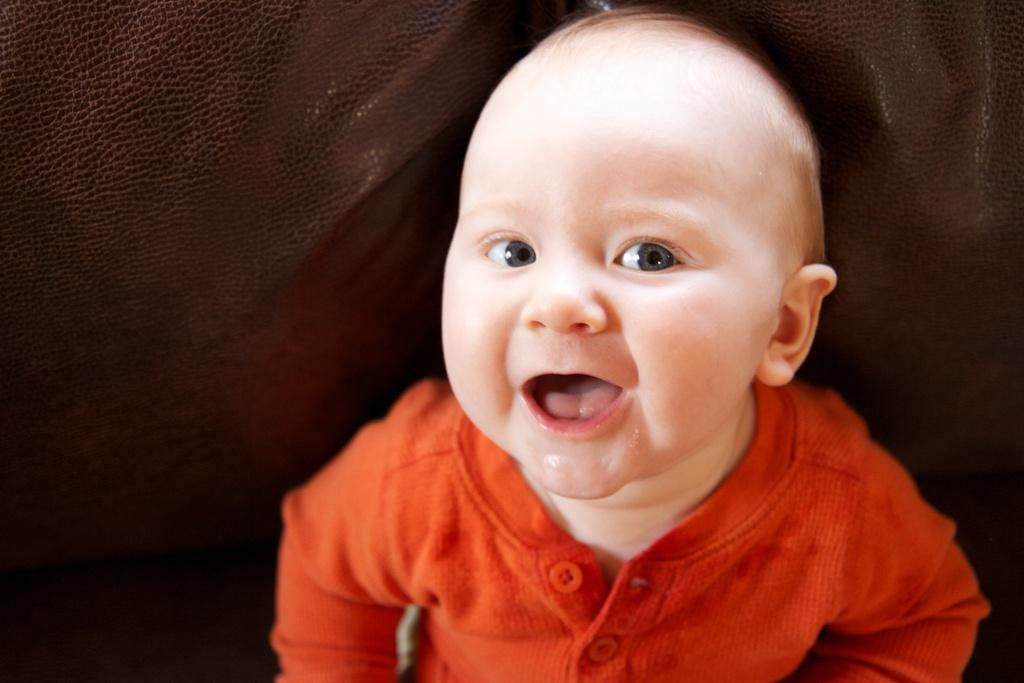What is the main subject of the picture? The main subject of the picture is a boy. What is the boy wearing in the picture? The boy is wearing a red t-shirt in the picture. What is the boy's facial expression in the picture? The boy is smiling in the picture. What is the boy doing in the picture? The boy is posing for the camera in the picture. What color is the background in the picture? The background in the picture is brown. What type of board is the boy holding in the picture? There is no board present in the picture; the boy is wearing a red t-shirt and posing for the camera. Can you tell me how the boy is blowing a bubble in the picture? There is no bubble or blowing action present in the picture; the boy is simply smiling and posing for the camera. 